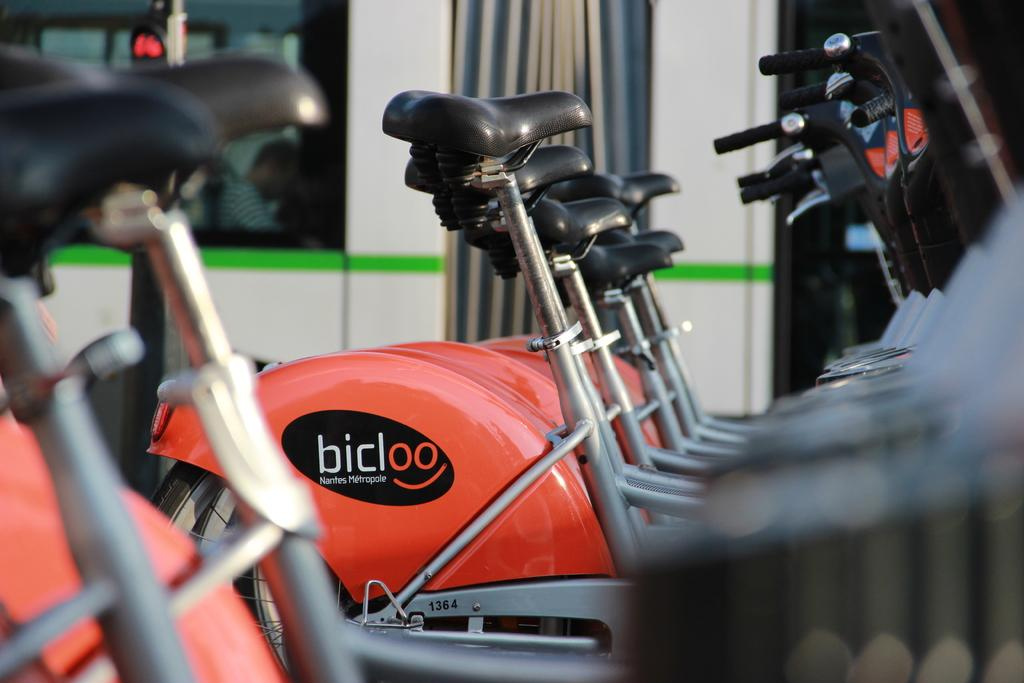What type of vehicles are in the image? There are bicycles in the image. What can be seen in the background of the image? There is a wall, glass doors, a light, and a pole in the background of the image. What type of machine is used to prepare the stew in the image? There is no machine or stew present in the image. 